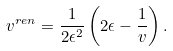Convert formula to latex. <formula><loc_0><loc_0><loc_500><loc_500>v ^ { r e n } = \frac { 1 } { 2 \epsilon ^ { 2 } } \left ( 2 \epsilon - \frac { 1 } { v } \right ) .</formula> 